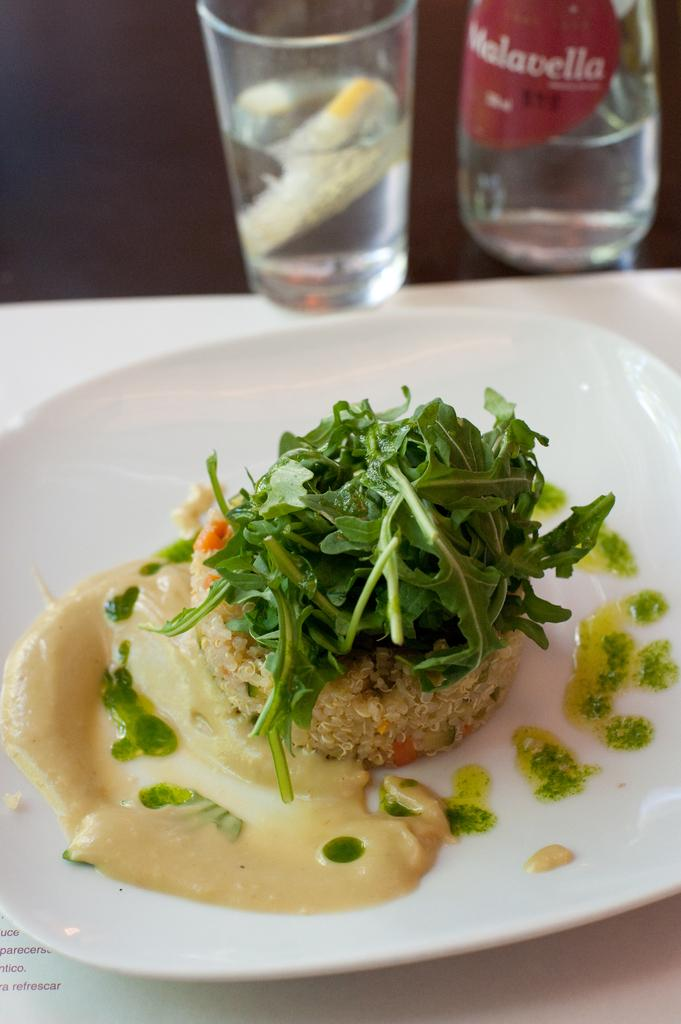What is on the table in the image? There is a plate and glasses on the table. What is on the plate? The plate contains leafy vegetables, cream, and rice. What type of belief is depicted on the plate in the image? There is no belief depicted on the plate in the image; it contains leafy vegetables, cream, and rice. 